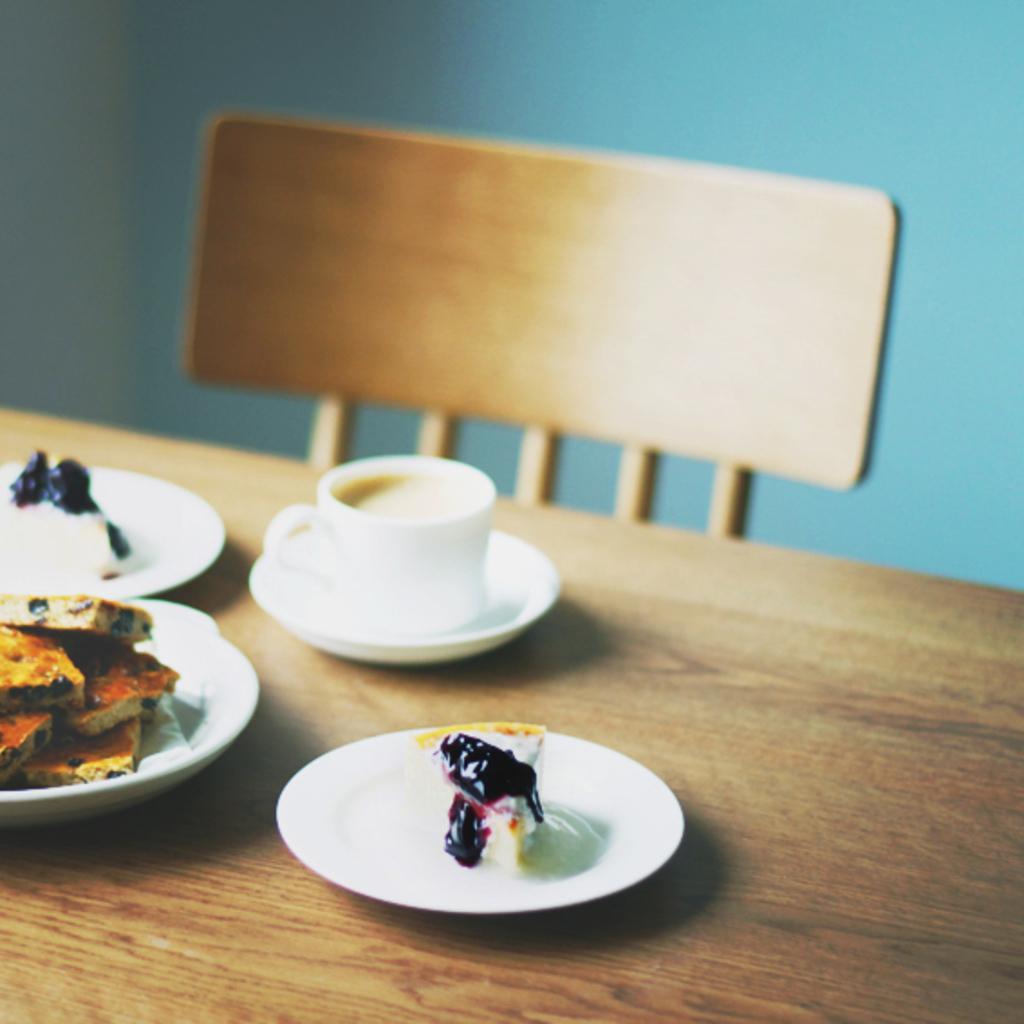Can you describe this image briefly? In this image there is a table and on top of it there is a plate, cup and a coffee in it, a saucer, biscuits and a cake on it. At the background there is a wall and an empty chair. 